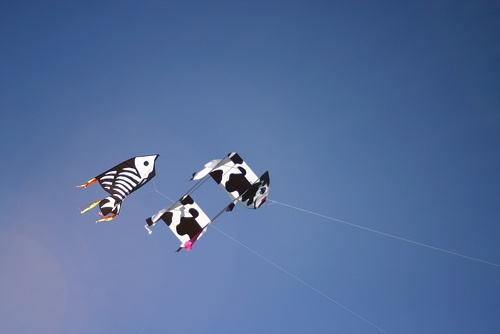Describe the objects in this image and their specific colors. I can see kite in darkblue, black, white, darkgray, and gray tones, kite in darkblue, white, black, gray, and darkgray tones, and kite in darkblue, white, black, darkgray, and gray tones in this image. 